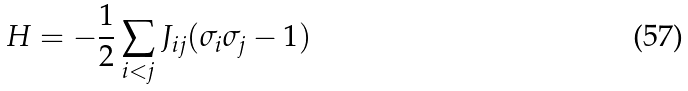<formula> <loc_0><loc_0><loc_500><loc_500>H = - \frac { 1 } { 2 } \sum _ { i < j } J _ { i j } ( \sigma _ { i } \sigma _ { j } - 1 )</formula> 